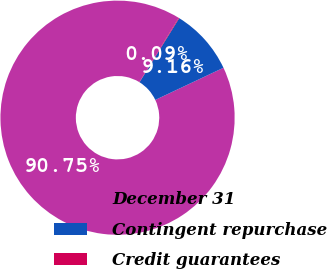Convert chart to OTSL. <chart><loc_0><loc_0><loc_500><loc_500><pie_chart><fcel>December 31<fcel>Contingent repurchase<fcel>Credit guarantees<nl><fcel>90.75%<fcel>9.16%<fcel>0.09%<nl></chart> 